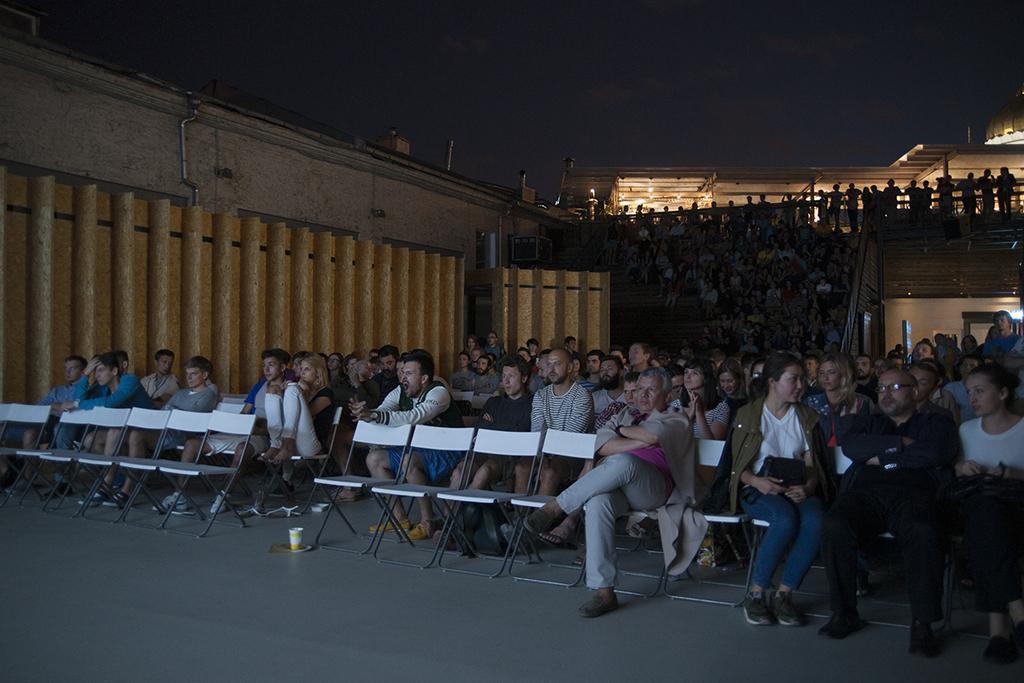Can you describe this image briefly? In this image we can see a group of people sitting on chairs. On the right side of the image we can see some people standing, we can also see some lights and a shed. In the left side of the image we can see a glass placed on the surface and some pipes on the wall. In the center of the image we can see a container. At the top of the image we can see the sky. 